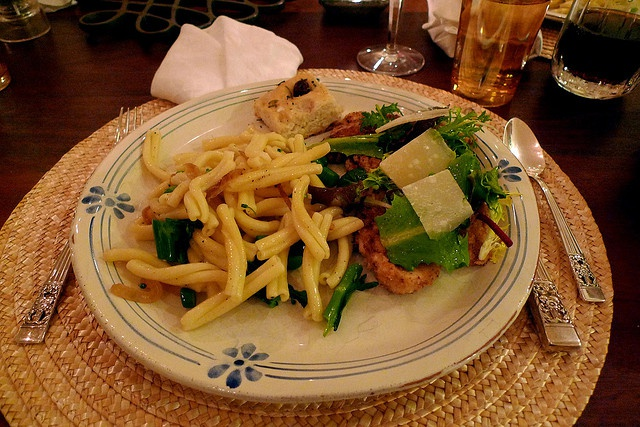Describe the objects in this image and their specific colors. I can see dining table in black, maroon, brown, and tan tones, cup in black, olive, and maroon tones, cup in black, maroon, and brown tones, spoon in black, tan, gray, and olive tones, and fork in black, brown, maroon, and gray tones in this image. 